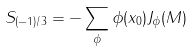<formula> <loc_0><loc_0><loc_500><loc_500>S _ { ( - 1 ) / 3 } = - \sum _ { \phi } \phi ( x _ { 0 } ) J _ { \phi } ( M )</formula> 